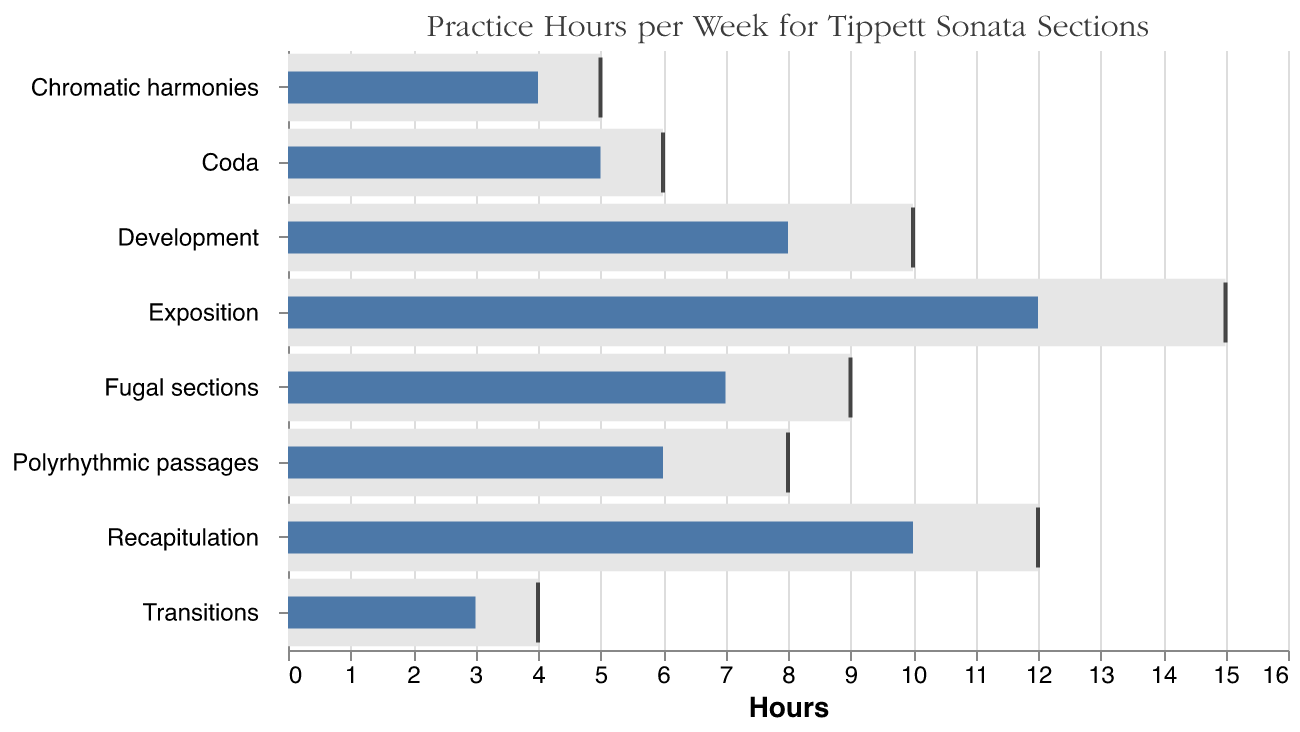What's the title of the figure? The title is typically displayed at the top of the chart. It provides context for what the figure represents. In this figure, the title reads "Practice Hours per Week for Tippett Sonata Sections."
Answer: Practice Hours per Week for Tippett Sonata Sections What section has the highest practice hours goal? The chart includes goals for each section, represented by ticks. The section with the highest tick value represents the highest goal. In this chart, the Exposition has a goal of 15 hours, which is the highest.
Answer: Exposition How many sections have practice hours goals less than or equal to 5? Review each section's goal, and count how many goals are 5 hours or less. Chromatic harmonies (5), Transitions (4), Coda (6) but only exceeds this by 1 hour. Thus, there are 2 sections with goals ≤ 5 hours.
Answer: 2 sections What's the total of actual practice hours for all sections combined? Add the actual practice hours for each section: 12 (Exposition) + 8 (Development) + 10 (Recapitulation) + 5 (Coda) + 3 (Transitions) + 6 (Polyrhythmic passages) + 7 (Fugal sections) + 4 (Chromatic harmonies). This sums up to: 55 hours.
Answer: 55 hours How much more practice hours does the Exposition need to meet its goal? Subtract the actual practice hours for the Exposition (12) from its goal (15): 15 - 12 = 3 hours.
Answer: 3 hours Which section has the smallest difference between actual practice hours and goal? Calculate the difference between actual and goal for each section: Exposition (3), Development (2), Recapitulation (2), Coda (1), Transitions (1), Polyrhythmic passages (2), Fugal sections (2), Chromatic harmonies (1). The smallest difference (1 hour) is observed in Coda, Transitions, and Chromatic harmonies.
Answer: Coda, Transitions, Chromatic harmonies How many sections have practice hours exceeding 6 hours? Review the actual practice hours for each section: Exposition (12), Development (8), Recapitulation (10), Coda (5), Transitions (3), Polyrhythmic passages (6), Fugal sections (7), Chromatic harmonies (4). The sections exceeding 6 hours are Exposition, Development, Recapitulation, and Fugal sections.
Answer: 4 sections Which section has the highest discrepancy between the actual practice hours and the goal? Calculate the difference between actual hours and goals for each section: Exposition (3), Development (2), Recapitulation (2), Coda (1), Transitions (1), Polyrhythmic passages (2), Fugal sections (2), Chromatic harmonies (1). The highest discrepancy (3 hours) is for the Exposition.
Answer: Exposition What is the average goal for practice hours across all sections? Add the goals and divide by the number of sections: (15 + 10 + 12 + 6 + 4 + 8 + 9 + 5) / 8 = 69 / 8 = 8.625 hours.
Answer: 8.625 hours 